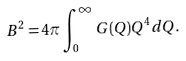Convert formula to latex. <formula><loc_0><loc_0><loc_500><loc_500>B ^ { 2 } = 4 \pi \int _ { 0 } ^ { \infty } G ( Q ) Q ^ { 4 } d Q .</formula> 